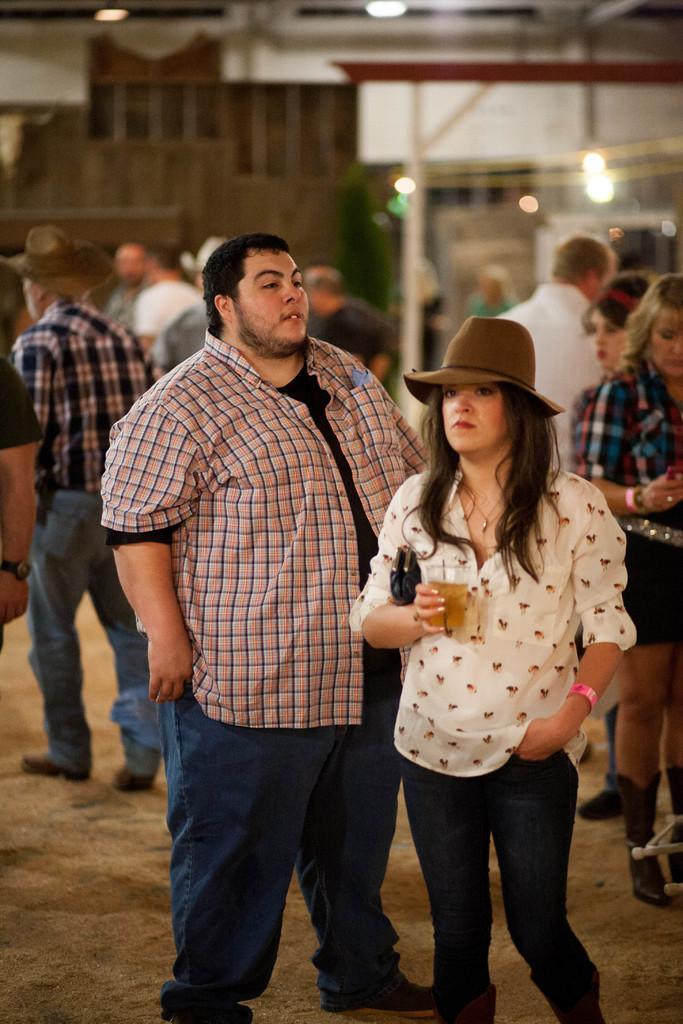How would you summarize this image in a sentence or two? Background portion of the picture is blur. In this picture we can see lights and few objects. On the right side of the picture we can see a woman wearing a hat and she is holding a glass in her hand. We can see drink in the glass. 